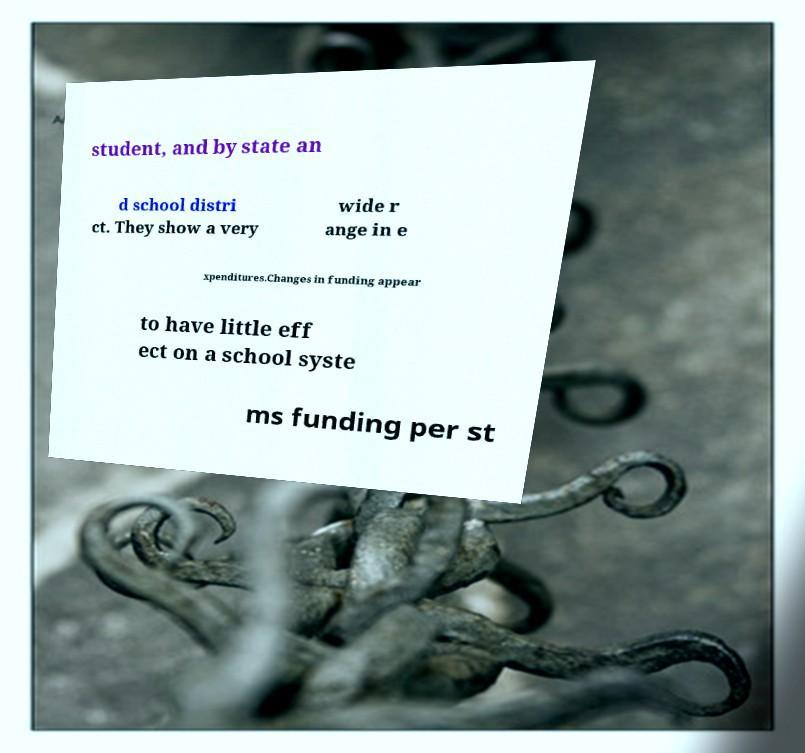For documentation purposes, I need the text within this image transcribed. Could you provide that? student, and by state an d school distri ct. They show a very wide r ange in e xpenditures.Changes in funding appear to have little eff ect on a school syste ms funding per st 